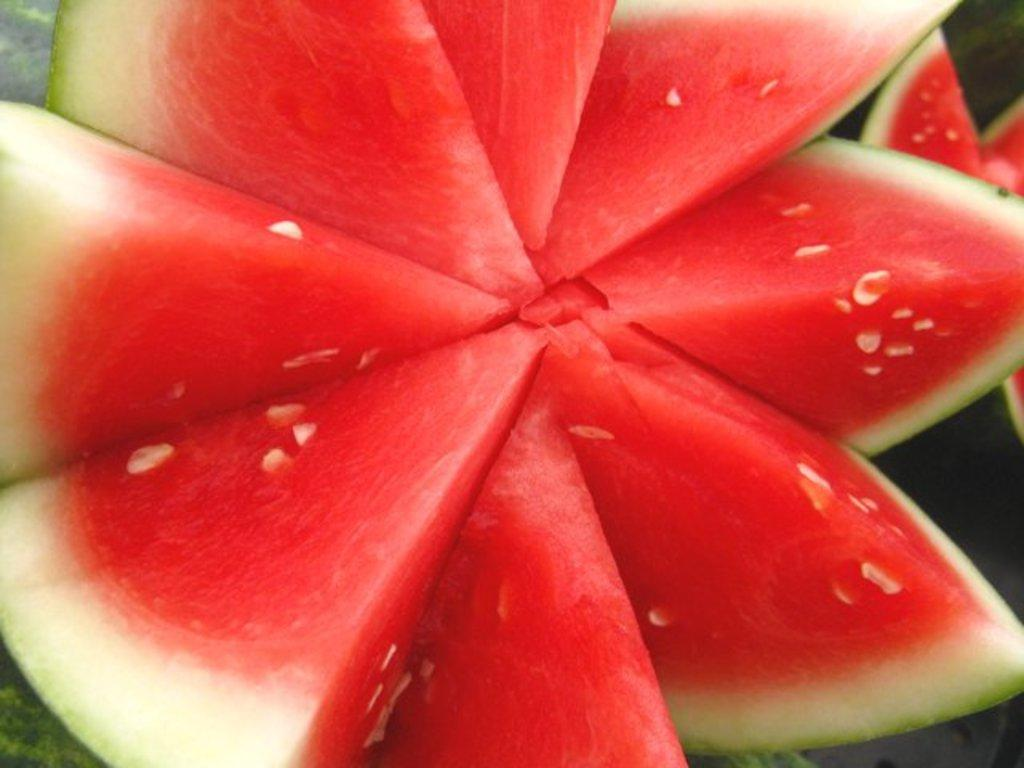What is the main subject in the foreground of the image? There is a watermelon in the foreground of the image. Can you describe any other watermelons in the image? Yes, there is another watermelon on the right side of the image. How does the watermelon run across the image? Watermelons do not have the ability to run, and there is no indication of movement in the image. 